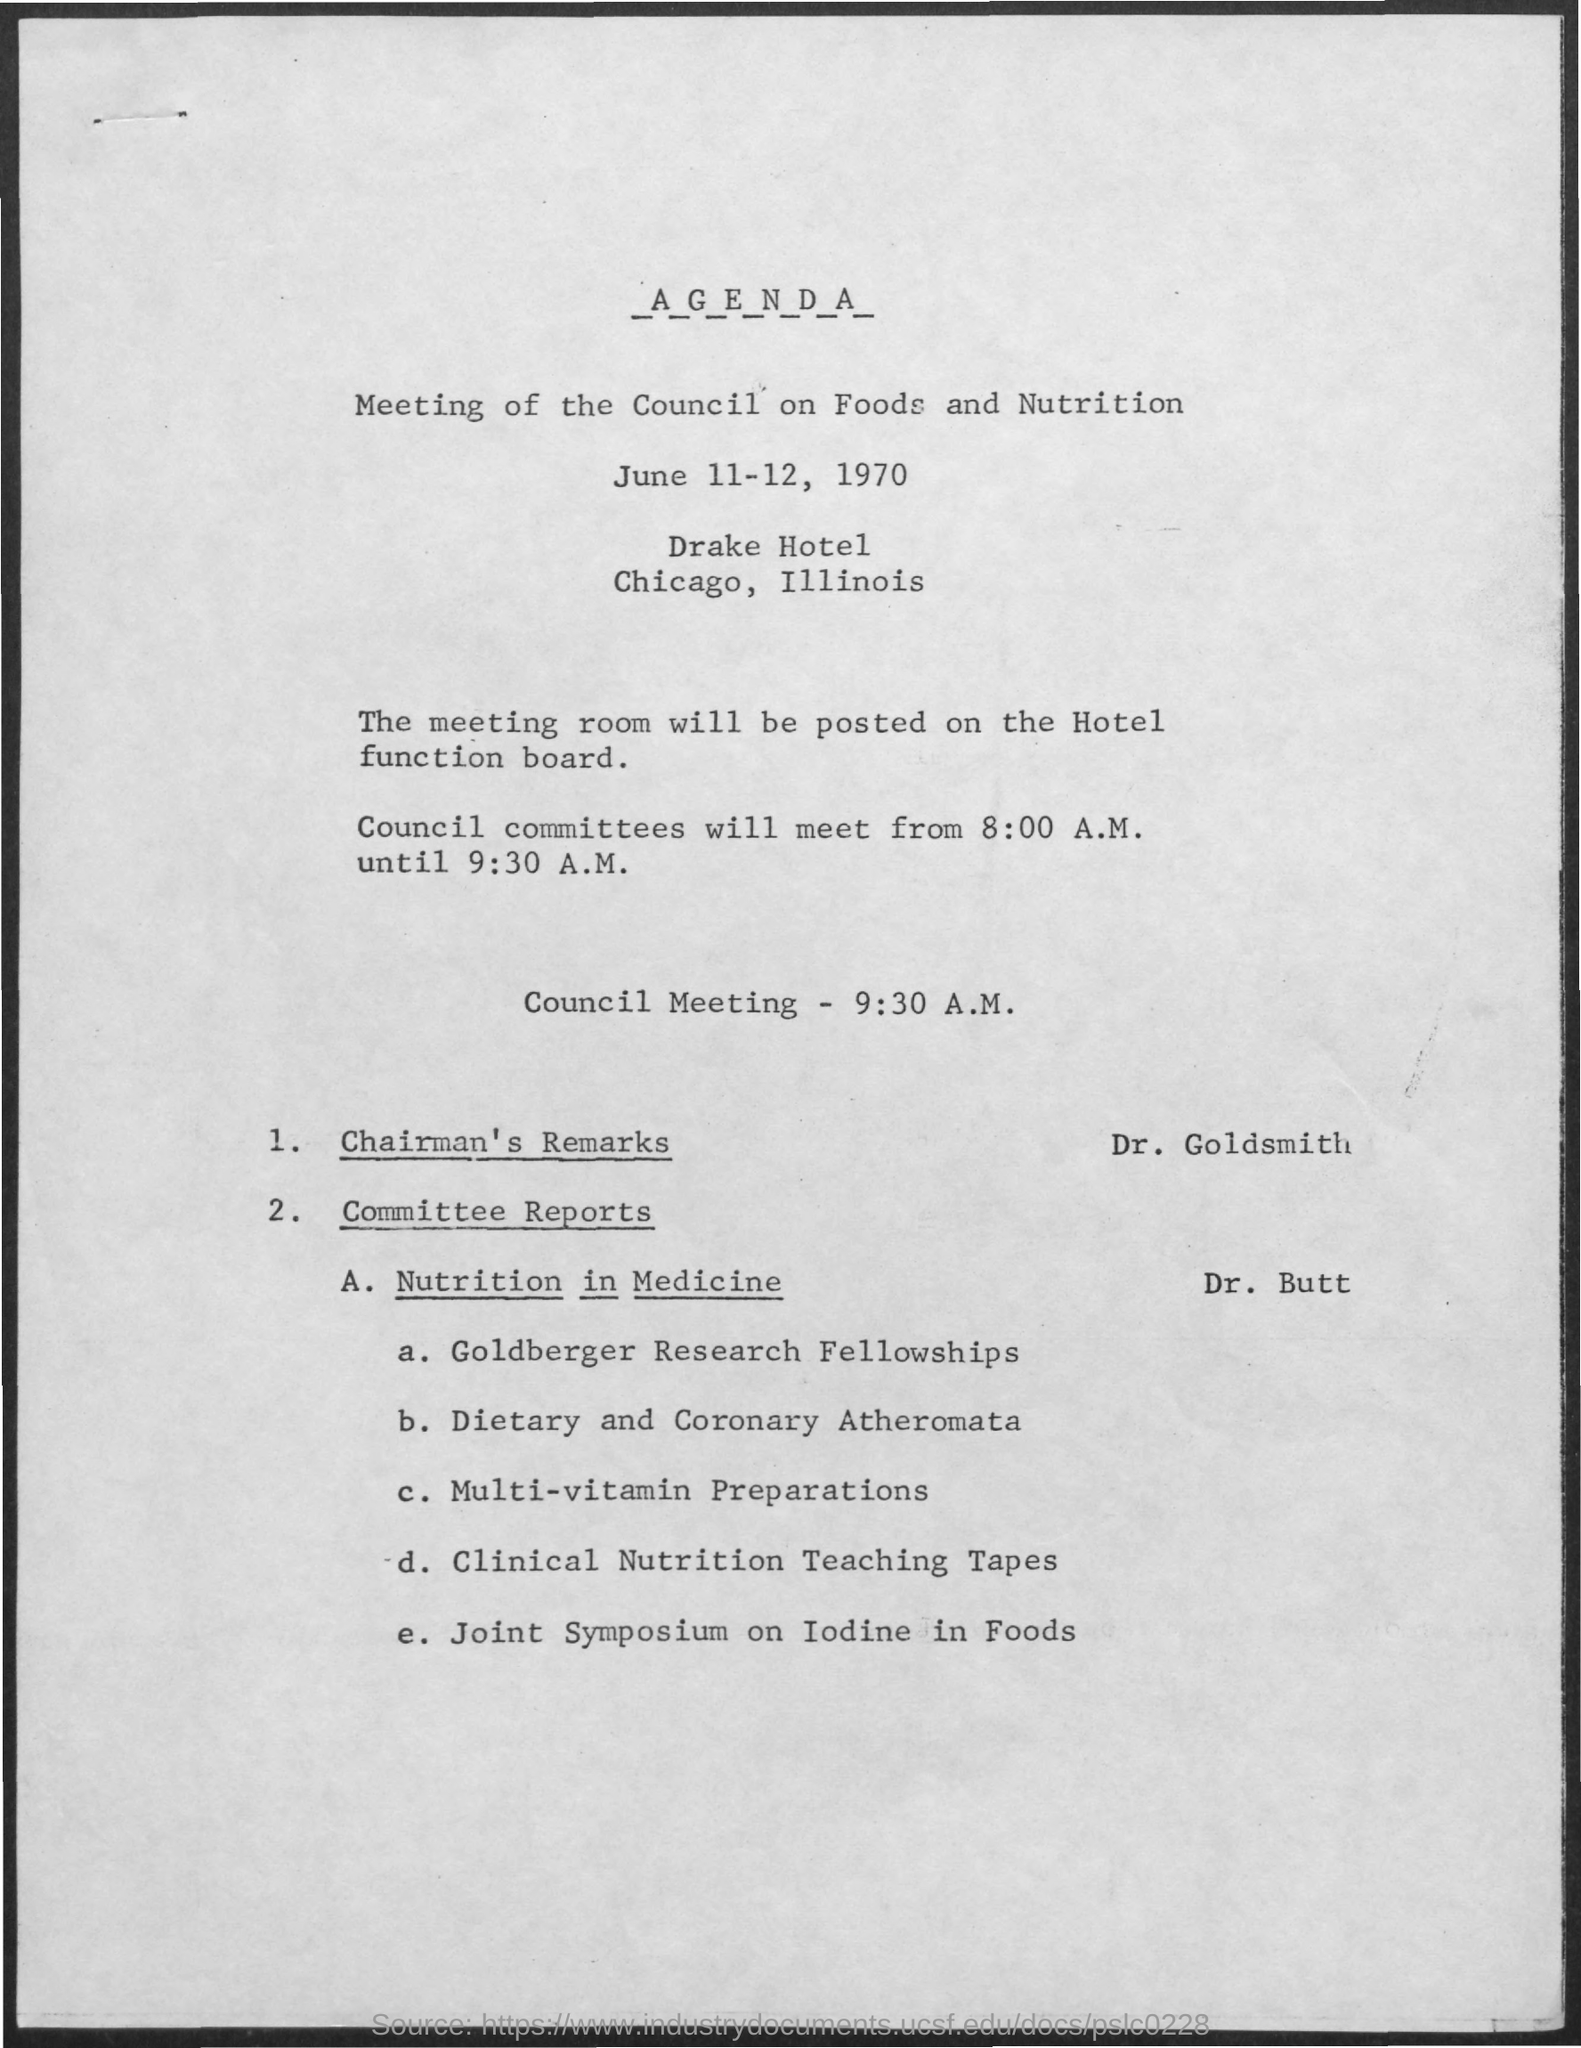Point out several critical features in this image. The council meeting will commence at 9:30 A.M. as per the agenda. The speaker announced that Dr. Goldsmith will be presenting the chairman's remarks as per the agenda. The meeting of the council on Foods and Nutrition is scheduled for June 11-12, 1970. The speaker will be presenting the Committee reports on Nutrition in Medicine. The presenter is Dr. Butt. 